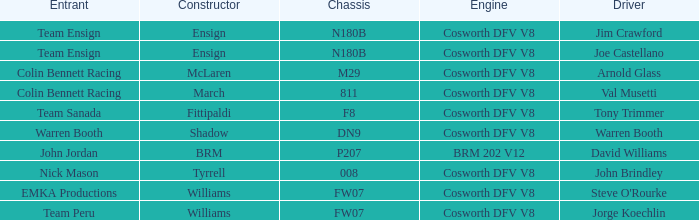Who built the Jim Crawford car? Ensign. 